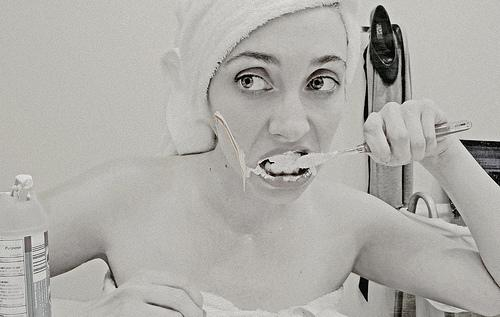Question: what color is the toothbrush?
Choices:
A. Red.
B. Purple.
C. White.
D. Clear.
Answer with the letter. Answer: D Question: where is this person?
Choices:
A. Bathroom.
B. Kitchen.
C. Bedroom.
D. Living room.
Answer with the letter. Answer: A Question: how many people are in the picture?
Choices:
A. One.
B. Two.
C. Three.
D. Four.
Answer with the letter. Answer: A Question: what is this girl doing?
Choices:
A. Looking in the mirror.
B. Flossing her teeth.
C. Brushing her teeth.
D. Putting on makeup.
Answer with the letter. Answer: C Question: when was this photo taken?
Choices:
A. While she was cooking.
B. While she was in the bathroom.
C. While she was packing.
D. While she was cleaning.
Answer with the letter. Answer: B 